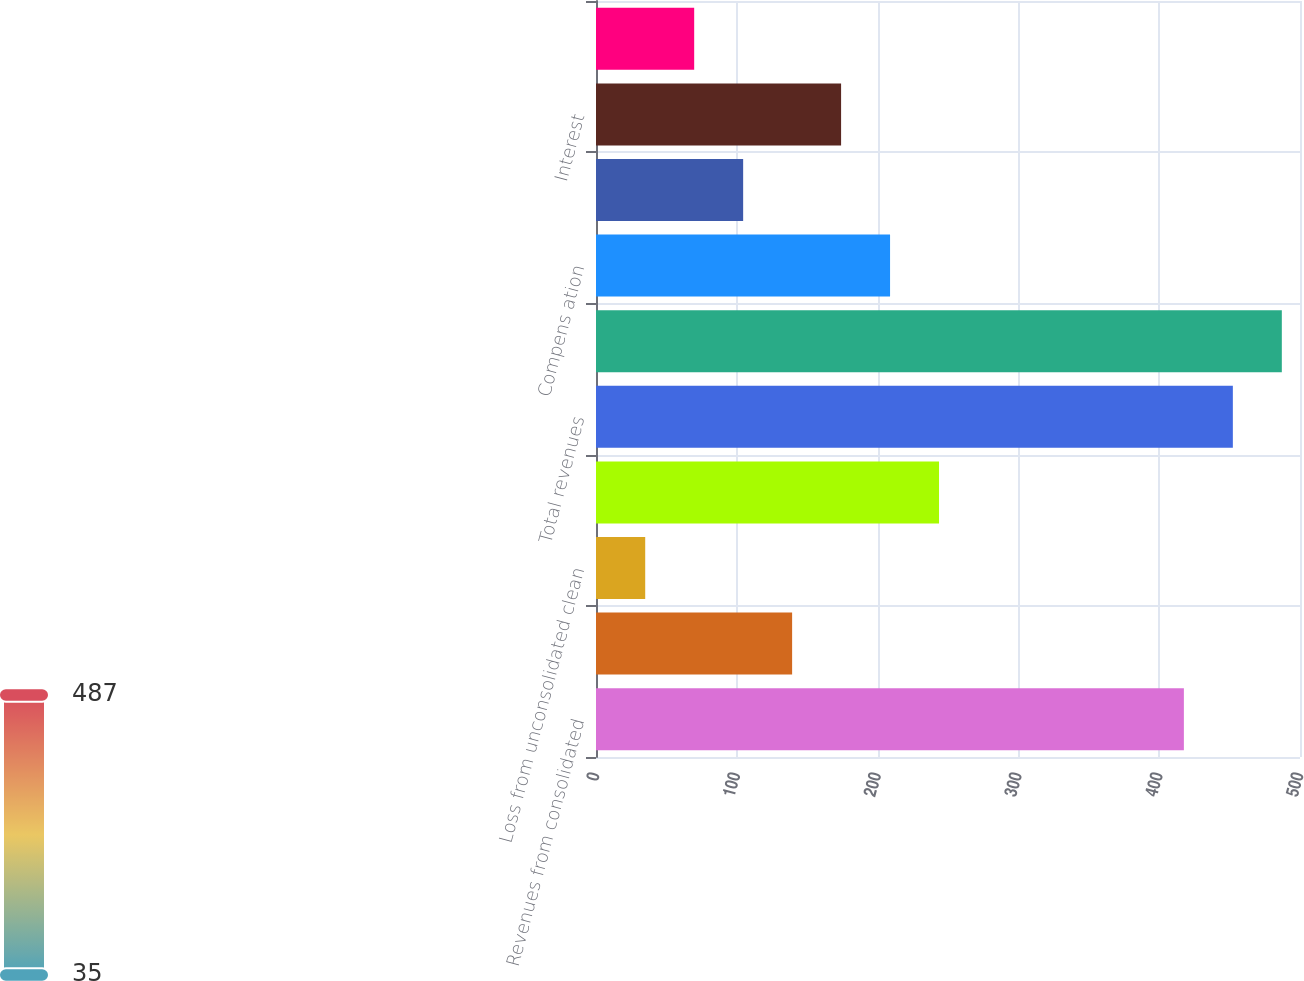Convert chart to OTSL. <chart><loc_0><loc_0><loc_500><loc_500><bar_chart><fcel>Revenues from consolidated<fcel>Royalty income from clean coal<fcel>Loss from unconsolidated clean<fcel>Other net revenues<fcel>Total revenues<fcel>Cost of revenues from<fcel>Compens ation<fcel>Operating<fcel>Interest<fcel>Depreciation<nl><fcel>417.53<fcel>139.29<fcel>34.95<fcel>243.63<fcel>452.31<fcel>487.09<fcel>208.85<fcel>104.51<fcel>174.07<fcel>69.73<nl></chart> 